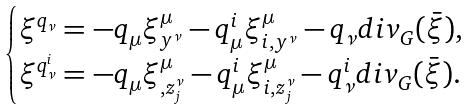<formula> <loc_0><loc_0><loc_500><loc_500>\begin{cases} \xi ^ { q _ { \nu } } = - q _ { \mu } \xi ^ { \mu } _ { y ^ { \nu } } - q ^ { i } _ { \mu } \xi ^ { \mu } _ { i , y ^ { \nu } } - q _ { \nu } d i v _ { G } ( \bar { \xi } ) , \\ \xi ^ { q ^ { i } _ { \nu } } = - q _ { \mu } \xi ^ { \mu } _ { , z ^ { \nu } _ { j } } - q ^ { i } _ { \mu } \xi ^ { \mu } _ { i , z ^ { \nu } _ { j } } - q ^ { i } _ { \nu } d i v _ { G } ( \bar { \xi } ) . \end{cases}</formula> 